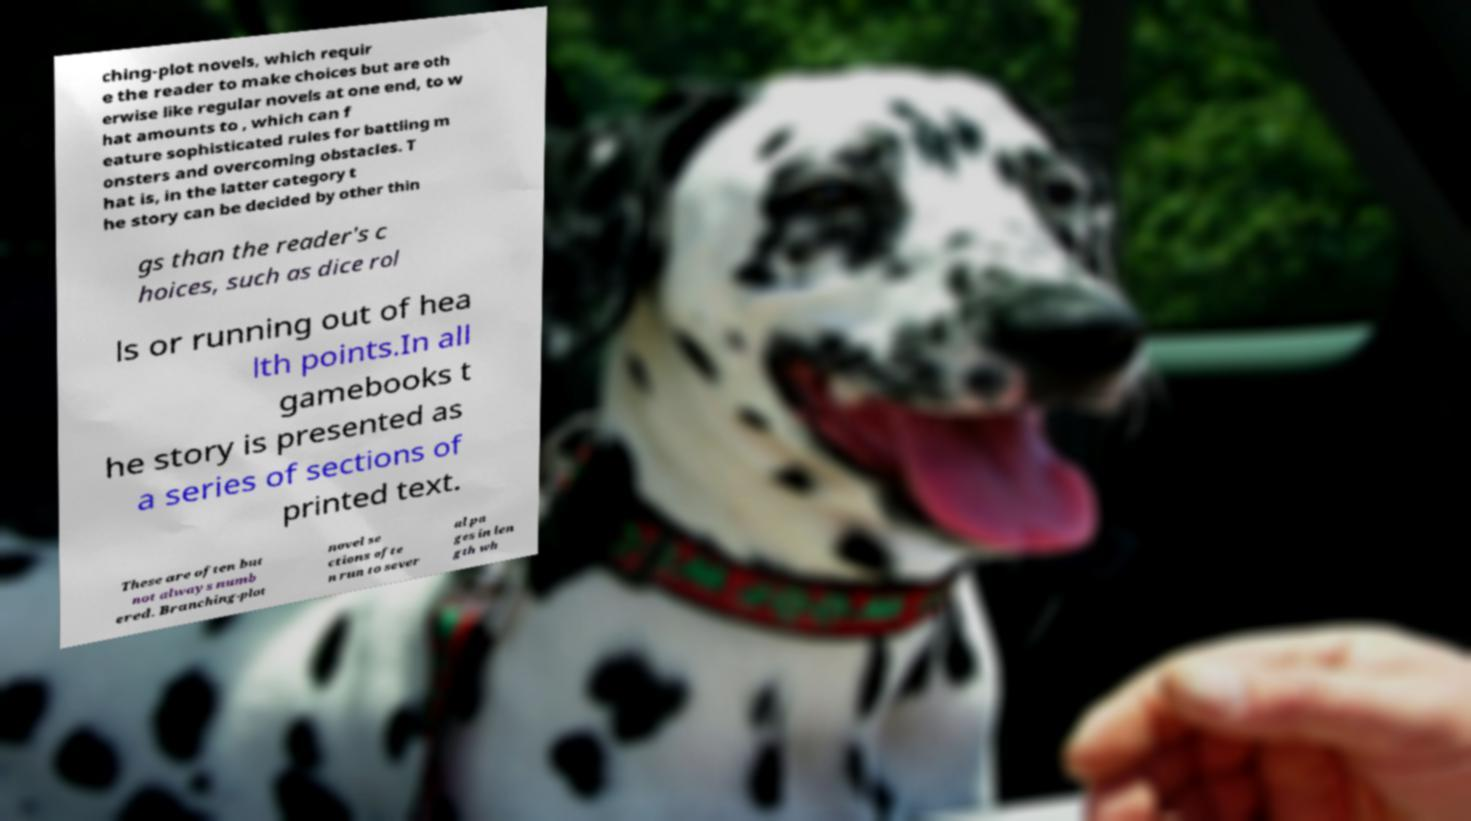There's text embedded in this image that I need extracted. Can you transcribe it verbatim? ching-plot novels, which requir e the reader to make choices but are oth erwise like regular novels at one end, to w hat amounts to , which can f eature sophisticated rules for battling m onsters and overcoming obstacles. T hat is, in the latter category t he story can be decided by other thin gs than the reader's c hoices, such as dice rol ls or running out of hea lth points.In all gamebooks t he story is presented as a series of sections of printed text. These are often but not always numb ered. Branching-plot novel se ctions ofte n run to sever al pa ges in len gth wh 